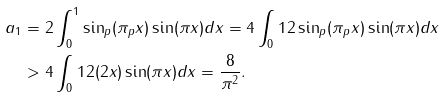<formula> <loc_0><loc_0><loc_500><loc_500>a _ { 1 } & = 2 \int _ { 0 } ^ { 1 } \sin _ { p } ( \pi _ { p } x ) \sin ( \pi x ) d x = 4 \int _ { 0 } ^ { } { 1 } 2 \sin _ { p } ( \pi _ { p } x ) \sin ( \pi x ) d x \\ & > 4 \int _ { 0 } ^ { } { 1 } 2 ( 2 x ) \sin ( \pi x ) d x = \frac { 8 } { \pi ^ { 2 } } .</formula> 